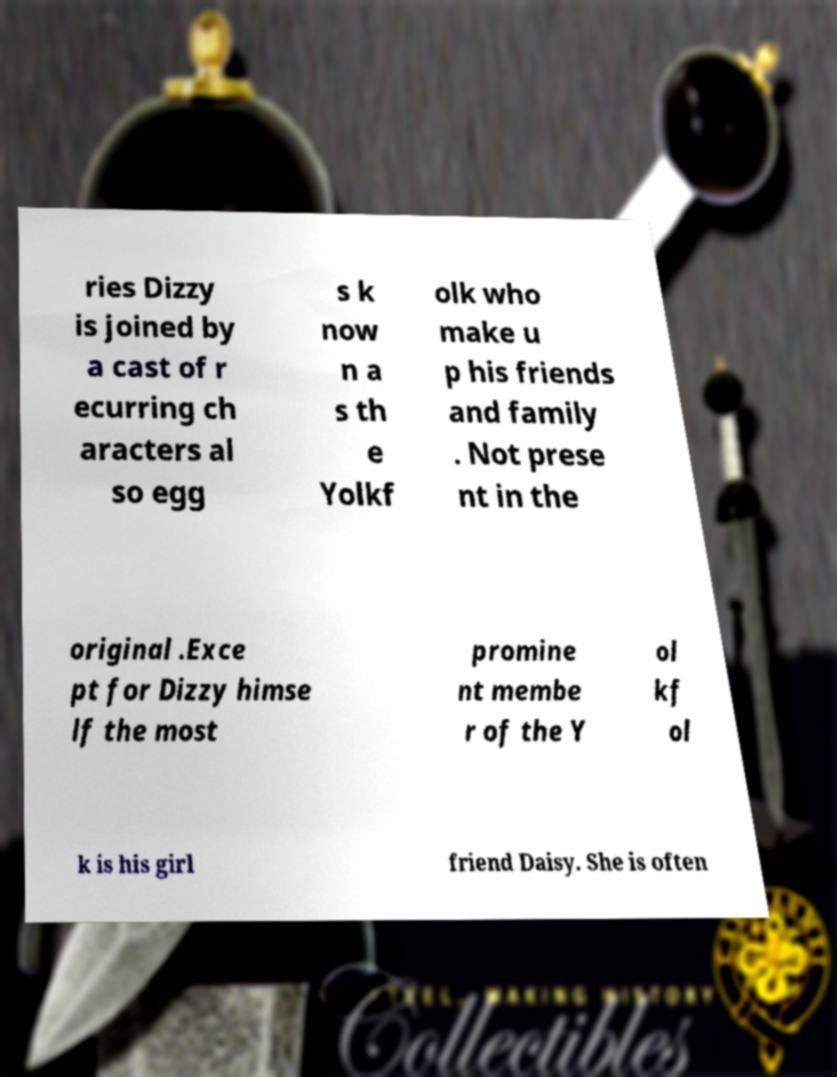Could you assist in decoding the text presented in this image and type it out clearly? ries Dizzy is joined by a cast of r ecurring ch aracters al so egg s k now n a s th e Yolkf olk who make u p his friends and family . Not prese nt in the original .Exce pt for Dizzy himse lf the most promine nt membe r of the Y ol kf ol k is his girl friend Daisy. She is often 